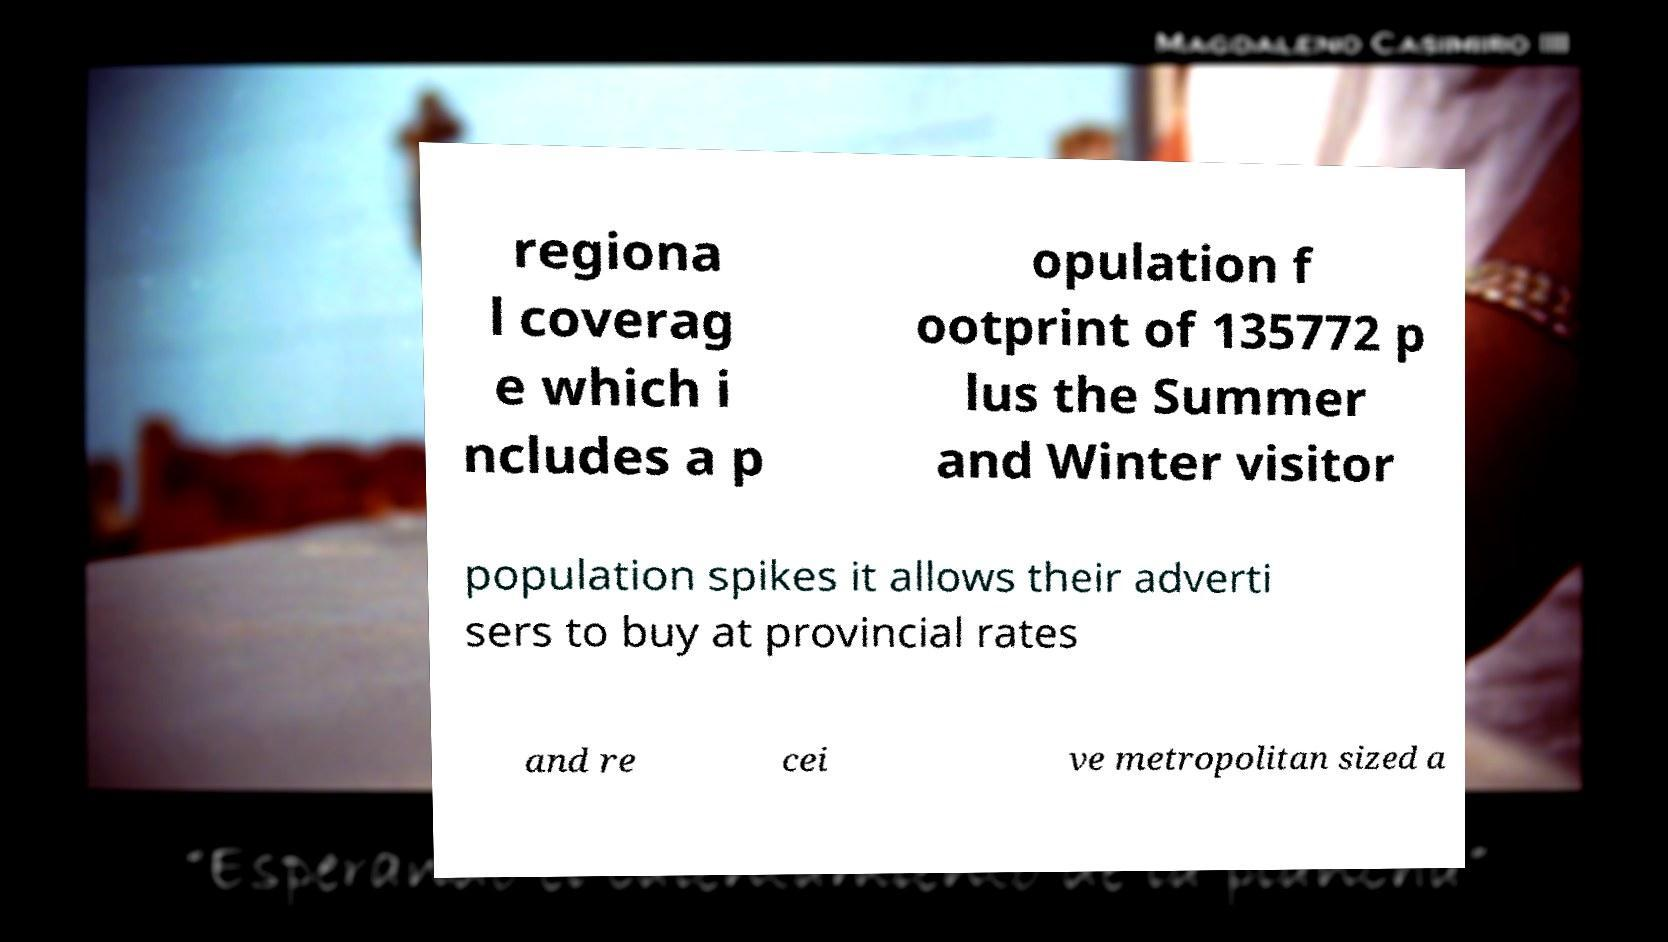Could you extract and type out the text from this image? regiona l coverag e which i ncludes a p opulation f ootprint of 135772 p lus the Summer and Winter visitor population spikes it allows their adverti sers to buy at provincial rates and re cei ve metropolitan sized a 